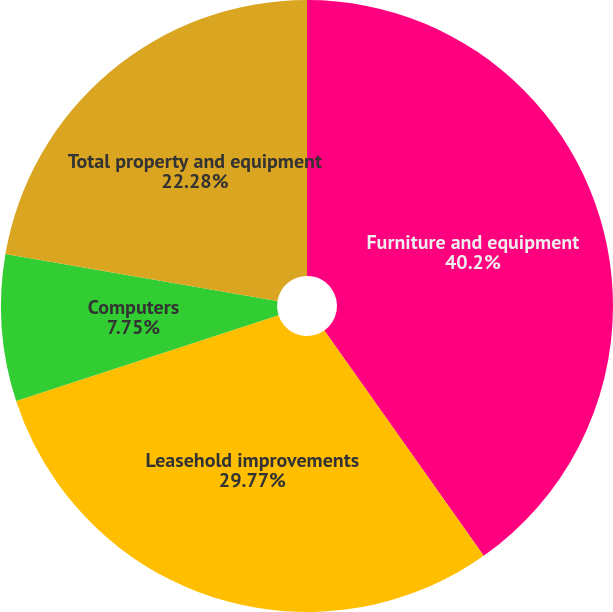Convert chart. <chart><loc_0><loc_0><loc_500><loc_500><pie_chart><fcel>Furniture and equipment<fcel>Leasehold improvements<fcel>Computers<fcel>Total property and equipment<nl><fcel>40.2%<fcel>29.77%<fcel>7.75%<fcel>22.28%<nl></chart> 